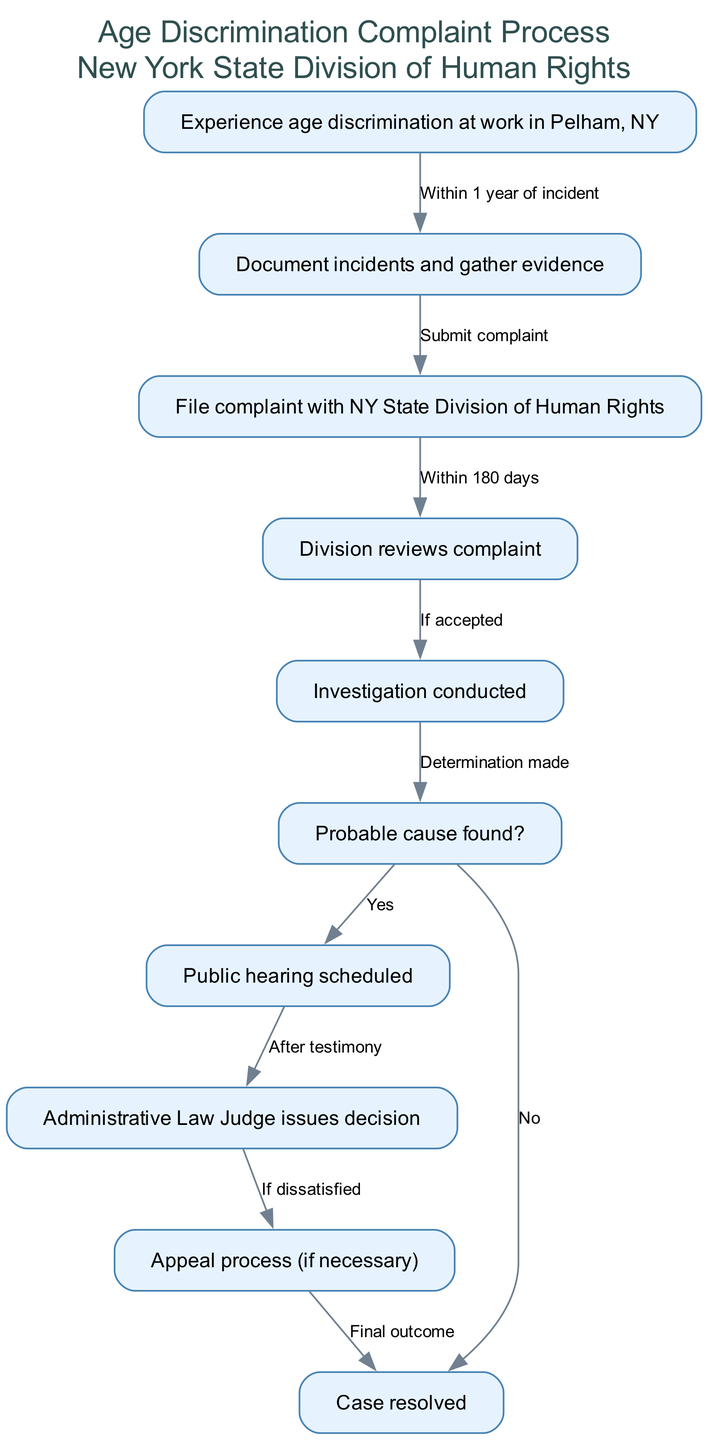What is the first step after experiencing age discrimination? The first step indicated in the diagram is to "Document incidents and gather evidence." This follows directly from the node labeled "Experience age discrimination at work in Pelham, NY" which leads to the documentation process.
Answer: Document incidents and gather evidence How many nodes are in the diagram? The diagram lists 10 distinct nodes representing various steps in the age discrimination complaint process. By counting each unique node in the provided data, we find a total of 10.
Answer: 10 What must be submitted after documenting incidents? After documenting incidents and gathering evidence, the next step according to the diagram is to "File complaint with NY State Division of Human Rights." This is the direct progression from the documentation node.
Answer: File complaint with NY State Division of Human Rights What happens if probable cause is found during the investigation? If probable cause is found, as shown in the diagram, the process leads to a "Public hearing scheduled." This outcome is the direct consequence of a positive determination made during the investigation step.
Answer: Public hearing scheduled How long do you have to file a complaint after experiencing discrimination? The diagram states that one must file a complaint "Within 1 year of incident." This timeframe is clearly indicated as a prerequisite to continuing the complaint process.
Answer: Within 1 year of incident What is the decision node based on? The decision node titled "Administrative Law Judge issues decision" is based on the information gathered during the "Public hearing scheduled" stage, which follows the investigation if probable cause was found. It reflects the culmination of the hearing process.
Answer: Public hearing scheduled What is the outcome if the decision is unsatisfactory? If the administrative law judge's decision is unsatisfactory, the diagram indicates that the next step concerns an "Appeal process (if necessary)." This prompts further action directed toward appealing the decision.
Answer: Appeal process (if necessary) What is the final outcome in the complaint process? The final outcome of the age discrimination complaint process is labeled "Case resolved," which concludes the flowchart. This follows various steps including potential appeals, indicating the end of the formal process.
Answer: Case resolved 